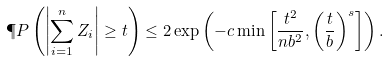Convert formula to latex. <formula><loc_0><loc_0><loc_500><loc_500>\P P \left ( \left | \sum _ { i = 1 } ^ { n } Z _ { i } \right | \geq t \right ) \leq 2 \exp \left ( - c \min \left [ \frac { t ^ { 2 } } { n b ^ { 2 } } , \left ( \frac { t } { b } \right ) ^ { s } \right ] \right ) .</formula> 